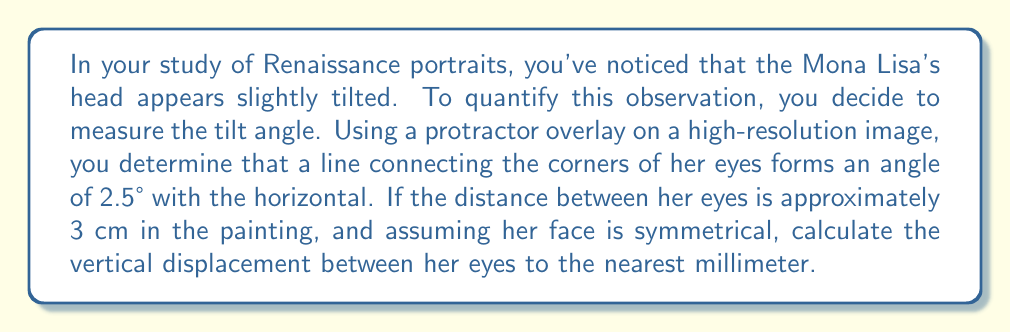Can you solve this math problem? To solve this problem, we can use basic trigonometry. Let's break it down step-by-step:

1) First, let's visualize the problem:

[asy]
import geometry;

pair A = (0,0);
pair B = (3,0);
pair C = (3,0.13);

draw(A--B--C--A);

label("3 cm", (1.5,-0.2), S);
label("x", (3.1,0.065), E);
label("2.5°", (0.2,0.1), NW);

draw(arc(A,0.5,0,2.5),Arrow);
[/asy]

2) We're dealing with a right triangle where:
   - The base is the distance between the eyes (3 cm)
   - The angle of tilt is 2.5°
   - We need to find the opposite side (vertical displacement)

3) This is a perfect scenario for the tangent function. Recall:

   $$\tan(\theta) = \frac{\text{opposite}}{\text{adjacent}}$$

4) In our case:

   $$\tan(2.5°) = \frac{x}{3}$$

   Where $x$ is the vertical displacement we're looking for.

5) Solving for $x$:

   $$x = 3 \cdot \tan(2.5°)$$

6) Using a calculator (or trigonometric tables):

   $$x = 3 \cdot 0.0436 = 0.1308 \text{ cm}$$

7) Converting to millimeters:

   $$0.1308 \text{ cm} = 13.08 \text{ mm}$$

8) Rounding to the nearest millimeter:

   $$13.08 \text{ mm} \approx 13 \text{ mm}$$
Answer: The vertical displacement between Mona Lisa's eyes is approximately 13 mm. 